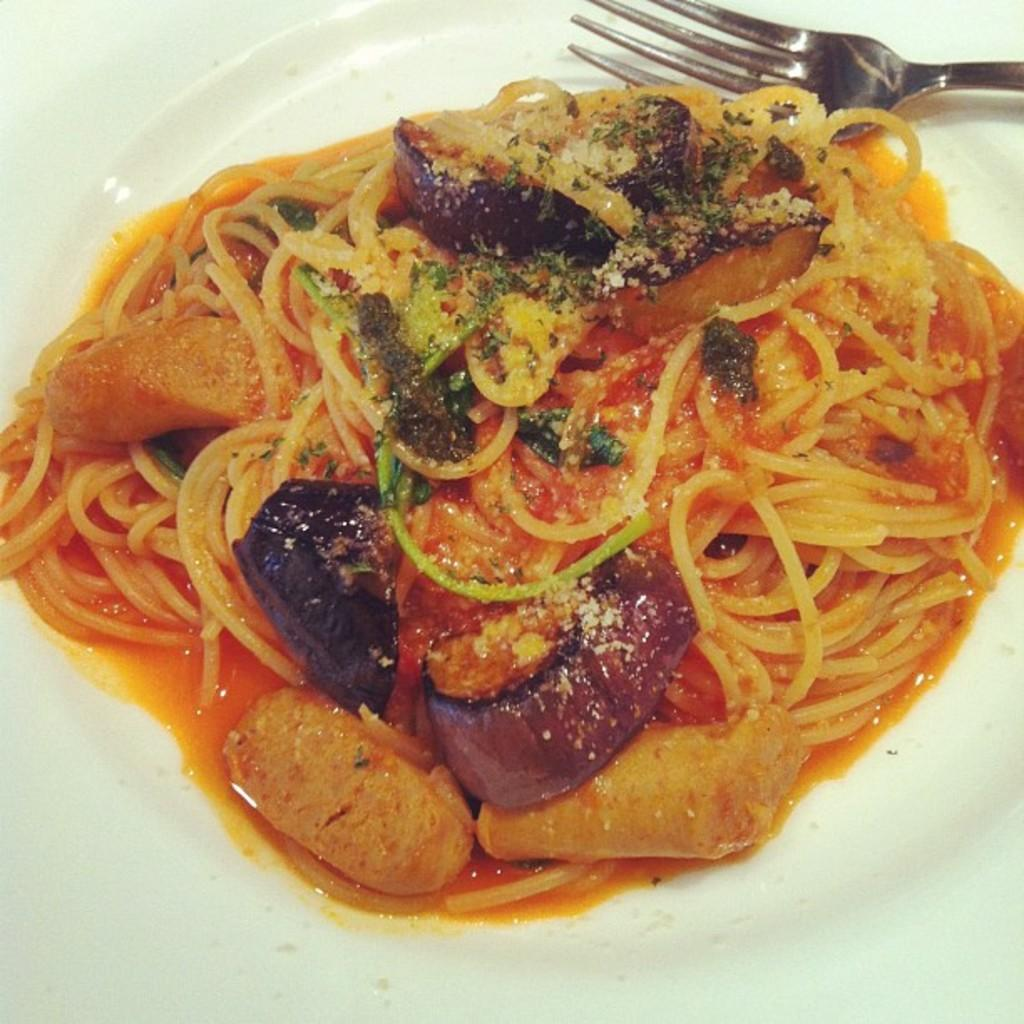What is on the plate that is visible in the image? The plate contains food items. What utensil is present in the image? There is a fork in the image. What type of question is being asked by the food on the plate? The food on the plate is not capable of asking questions, as it is an inanimate object. 